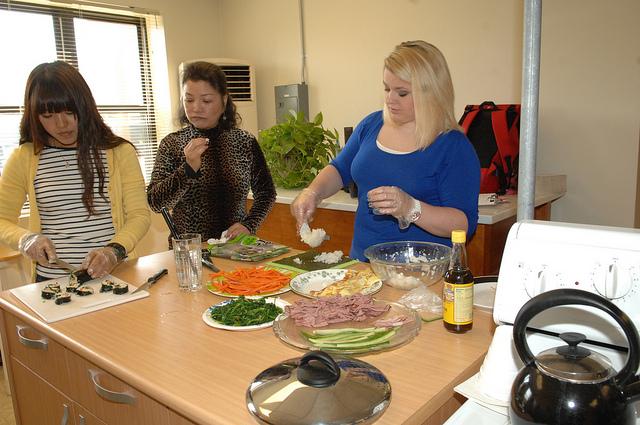What is being cut?
Give a very brief answer. Vegetables. Which room is this?
Give a very brief answer. Kitchen. Will they be eating soon?
Concise answer only. Yes. 